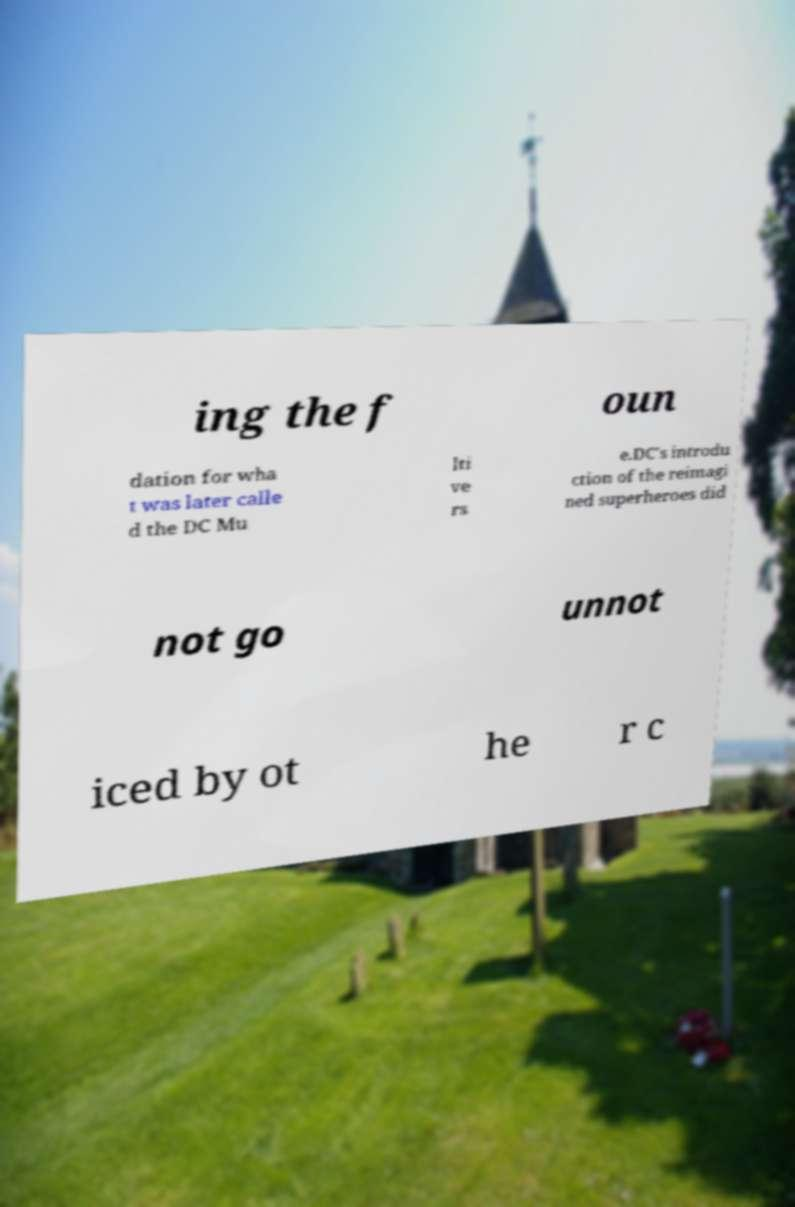There's text embedded in this image that I need extracted. Can you transcribe it verbatim? ing the f oun dation for wha t was later calle d the DC Mu lti ve rs e.DC's introdu ction of the reimagi ned superheroes did not go unnot iced by ot he r c 